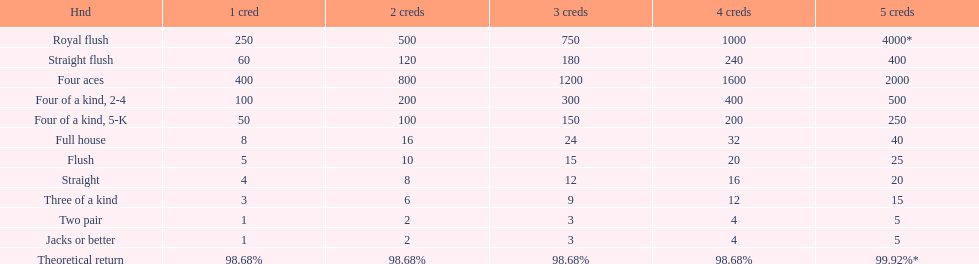What is the difference of payout on 3 credits, between a straight flush and royal flush? 570. 